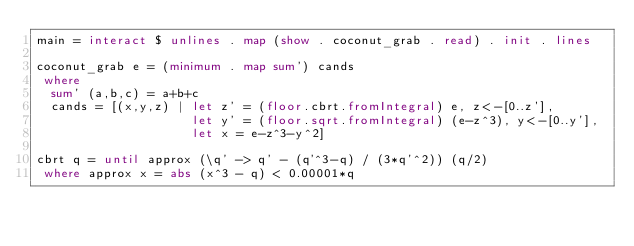Convert code to text. <code><loc_0><loc_0><loc_500><loc_500><_Haskell_>main = interact $ unlines . map (show . coconut_grab . read) . init . lines
 
coconut_grab e = (minimum . map sum') cands
 where
  sum' (a,b,c) = a+b+c
  cands = [(x,y,z) | let z' = (floor.cbrt.fromIntegral) e, z<-[0..z'],
                     let y' = (floor.sqrt.fromIntegral) (e-z^3), y<-[0..y'],
                     let x = e-z^3-y^2]

cbrt q = until approx (\q' -> q' - (q'^3-q) / (3*q'^2)) (q/2)
 where approx x = abs (x^3 - q) < 0.00001*q</code> 